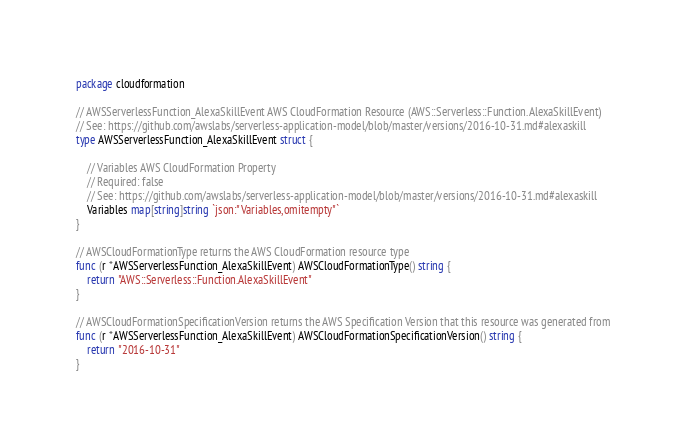Convert code to text. <code><loc_0><loc_0><loc_500><loc_500><_Go_>package cloudformation

// AWSServerlessFunction_AlexaSkillEvent AWS CloudFormation Resource (AWS::Serverless::Function.AlexaSkillEvent)
// See: https://github.com/awslabs/serverless-application-model/blob/master/versions/2016-10-31.md#alexaskill
type AWSServerlessFunction_AlexaSkillEvent struct {

	// Variables AWS CloudFormation Property
	// Required: false
	// See: https://github.com/awslabs/serverless-application-model/blob/master/versions/2016-10-31.md#alexaskill
	Variables map[string]string `json:"Variables,omitempty"`
}

// AWSCloudFormationType returns the AWS CloudFormation resource type
func (r *AWSServerlessFunction_AlexaSkillEvent) AWSCloudFormationType() string {
	return "AWS::Serverless::Function.AlexaSkillEvent"
}

// AWSCloudFormationSpecificationVersion returns the AWS Specification Version that this resource was generated from
func (r *AWSServerlessFunction_AlexaSkillEvent) AWSCloudFormationSpecificationVersion() string {
	return "2016-10-31"
}
</code> 